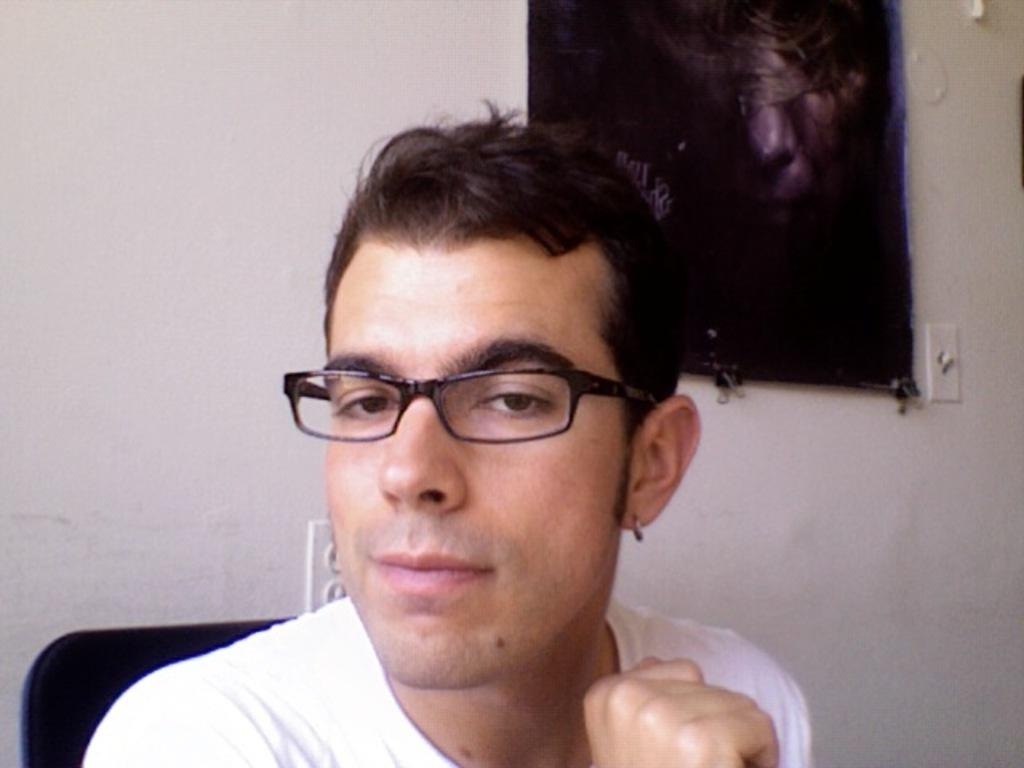Who is the main subject in the image? There is a boy in the center of the image. What else can be seen in the image besides the boy? There is a portrait on the right side of the image. How many chairs are visible in the image? There is no mention of chairs in the provided facts, so we cannot determine the number of chairs in the image. 